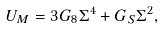Convert formula to latex. <formula><loc_0><loc_0><loc_500><loc_500>U _ { M } = 3 G _ { 8 } \Sigma ^ { 4 } + G _ { S } \Sigma ^ { 2 } ,</formula> 